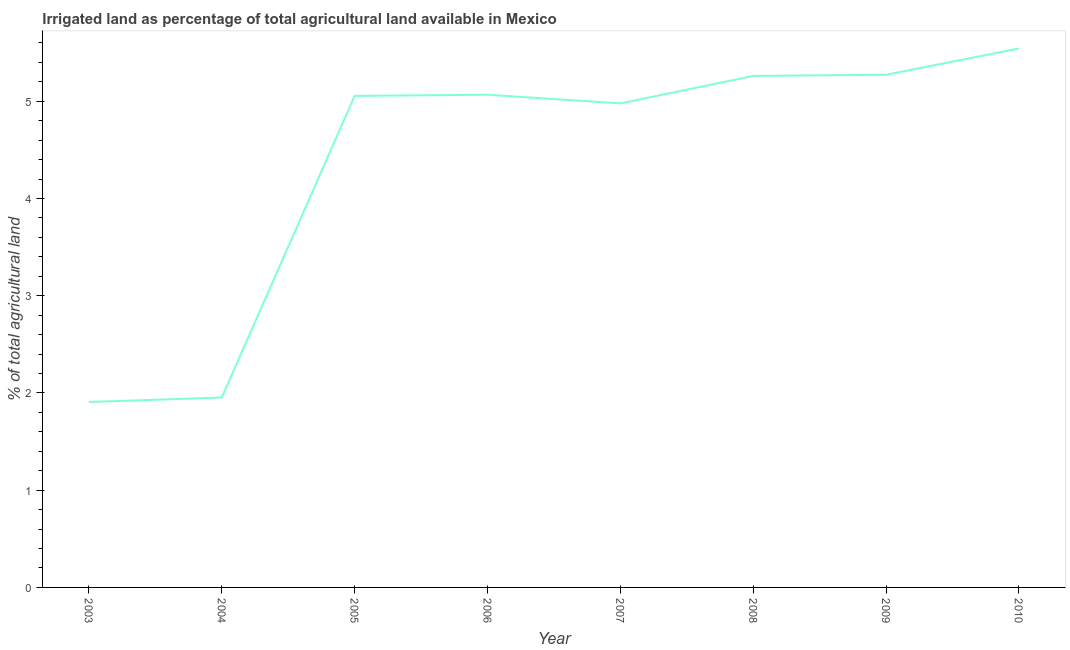What is the percentage of agricultural irrigated land in 2009?
Provide a short and direct response. 5.27. Across all years, what is the maximum percentage of agricultural irrigated land?
Make the answer very short. 5.54. Across all years, what is the minimum percentage of agricultural irrigated land?
Provide a short and direct response. 1.91. In which year was the percentage of agricultural irrigated land maximum?
Offer a terse response. 2010. What is the sum of the percentage of agricultural irrigated land?
Provide a succinct answer. 35.03. What is the difference between the percentage of agricultural irrigated land in 2008 and 2009?
Offer a terse response. -0.01. What is the average percentage of agricultural irrigated land per year?
Provide a short and direct response. 4.38. What is the median percentage of agricultural irrigated land?
Provide a succinct answer. 5.06. In how many years, is the percentage of agricultural irrigated land greater than 3.8 %?
Provide a short and direct response. 6. Do a majority of the years between 2009 and 2007 (inclusive) have percentage of agricultural irrigated land greater than 1.4 %?
Your answer should be very brief. No. What is the ratio of the percentage of agricultural irrigated land in 2005 to that in 2008?
Your answer should be compact. 0.96. Is the percentage of agricultural irrigated land in 2006 less than that in 2009?
Give a very brief answer. Yes. Is the difference between the percentage of agricultural irrigated land in 2007 and 2010 greater than the difference between any two years?
Your response must be concise. No. What is the difference between the highest and the second highest percentage of agricultural irrigated land?
Your answer should be very brief. 0.27. What is the difference between the highest and the lowest percentage of agricultural irrigated land?
Provide a short and direct response. 3.64. In how many years, is the percentage of agricultural irrigated land greater than the average percentage of agricultural irrigated land taken over all years?
Your answer should be very brief. 6. Does the percentage of agricultural irrigated land monotonically increase over the years?
Give a very brief answer. No. How many lines are there?
Keep it short and to the point. 1. How many years are there in the graph?
Your answer should be compact. 8. What is the difference between two consecutive major ticks on the Y-axis?
Your answer should be compact. 1. Are the values on the major ticks of Y-axis written in scientific E-notation?
Ensure brevity in your answer.  No. Does the graph contain any zero values?
Ensure brevity in your answer.  No. Does the graph contain grids?
Your answer should be compact. No. What is the title of the graph?
Keep it short and to the point. Irrigated land as percentage of total agricultural land available in Mexico. What is the label or title of the X-axis?
Keep it short and to the point. Year. What is the label or title of the Y-axis?
Provide a succinct answer. % of total agricultural land. What is the % of total agricultural land of 2003?
Keep it short and to the point. 1.91. What is the % of total agricultural land of 2004?
Give a very brief answer. 1.95. What is the % of total agricultural land of 2005?
Make the answer very short. 5.05. What is the % of total agricultural land in 2006?
Your response must be concise. 5.07. What is the % of total agricultural land in 2007?
Ensure brevity in your answer.  4.98. What is the % of total agricultural land in 2008?
Offer a very short reply. 5.26. What is the % of total agricultural land in 2009?
Provide a short and direct response. 5.27. What is the % of total agricultural land in 2010?
Ensure brevity in your answer.  5.54. What is the difference between the % of total agricultural land in 2003 and 2004?
Your response must be concise. -0.05. What is the difference between the % of total agricultural land in 2003 and 2005?
Offer a very short reply. -3.15. What is the difference between the % of total agricultural land in 2003 and 2006?
Your answer should be compact. -3.16. What is the difference between the % of total agricultural land in 2003 and 2007?
Your response must be concise. -3.07. What is the difference between the % of total agricultural land in 2003 and 2008?
Ensure brevity in your answer.  -3.35. What is the difference between the % of total agricultural land in 2003 and 2009?
Provide a short and direct response. -3.37. What is the difference between the % of total agricultural land in 2003 and 2010?
Offer a terse response. -3.64. What is the difference between the % of total agricultural land in 2004 and 2005?
Offer a very short reply. -3.1. What is the difference between the % of total agricultural land in 2004 and 2006?
Give a very brief answer. -3.11. What is the difference between the % of total agricultural land in 2004 and 2007?
Ensure brevity in your answer.  -3.02. What is the difference between the % of total agricultural land in 2004 and 2008?
Keep it short and to the point. -3.31. What is the difference between the % of total agricultural land in 2004 and 2009?
Provide a succinct answer. -3.32. What is the difference between the % of total agricultural land in 2004 and 2010?
Make the answer very short. -3.59. What is the difference between the % of total agricultural land in 2005 and 2006?
Make the answer very short. -0.01. What is the difference between the % of total agricultural land in 2005 and 2007?
Provide a succinct answer. 0.08. What is the difference between the % of total agricultural land in 2005 and 2008?
Provide a succinct answer. -0.21. What is the difference between the % of total agricultural land in 2005 and 2009?
Ensure brevity in your answer.  -0.22. What is the difference between the % of total agricultural land in 2005 and 2010?
Provide a succinct answer. -0.49. What is the difference between the % of total agricultural land in 2006 and 2007?
Your answer should be very brief. 0.09. What is the difference between the % of total agricultural land in 2006 and 2008?
Provide a succinct answer. -0.19. What is the difference between the % of total agricultural land in 2006 and 2009?
Your answer should be compact. -0.21. What is the difference between the % of total agricultural land in 2006 and 2010?
Offer a very short reply. -0.48. What is the difference between the % of total agricultural land in 2007 and 2008?
Keep it short and to the point. -0.28. What is the difference between the % of total agricultural land in 2007 and 2009?
Offer a terse response. -0.29. What is the difference between the % of total agricultural land in 2007 and 2010?
Offer a very short reply. -0.56. What is the difference between the % of total agricultural land in 2008 and 2009?
Offer a very short reply. -0.01. What is the difference between the % of total agricultural land in 2008 and 2010?
Your response must be concise. -0.28. What is the difference between the % of total agricultural land in 2009 and 2010?
Ensure brevity in your answer.  -0.27. What is the ratio of the % of total agricultural land in 2003 to that in 2005?
Ensure brevity in your answer.  0.38. What is the ratio of the % of total agricultural land in 2003 to that in 2006?
Offer a very short reply. 0.38. What is the ratio of the % of total agricultural land in 2003 to that in 2007?
Offer a very short reply. 0.38. What is the ratio of the % of total agricultural land in 2003 to that in 2008?
Provide a succinct answer. 0.36. What is the ratio of the % of total agricultural land in 2003 to that in 2009?
Your response must be concise. 0.36. What is the ratio of the % of total agricultural land in 2003 to that in 2010?
Offer a terse response. 0.34. What is the ratio of the % of total agricultural land in 2004 to that in 2005?
Offer a very short reply. 0.39. What is the ratio of the % of total agricultural land in 2004 to that in 2006?
Ensure brevity in your answer.  0.39. What is the ratio of the % of total agricultural land in 2004 to that in 2007?
Offer a very short reply. 0.39. What is the ratio of the % of total agricultural land in 2004 to that in 2008?
Provide a succinct answer. 0.37. What is the ratio of the % of total agricultural land in 2004 to that in 2009?
Your response must be concise. 0.37. What is the ratio of the % of total agricultural land in 2004 to that in 2010?
Provide a succinct answer. 0.35. What is the ratio of the % of total agricultural land in 2005 to that in 2006?
Make the answer very short. 1. What is the ratio of the % of total agricultural land in 2005 to that in 2009?
Your answer should be very brief. 0.96. What is the ratio of the % of total agricultural land in 2005 to that in 2010?
Keep it short and to the point. 0.91. What is the ratio of the % of total agricultural land in 2006 to that in 2010?
Ensure brevity in your answer.  0.91. What is the ratio of the % of total agricultural land in 2007 to that in 2008?
Make the answer very short. 0.95. What is the ratio of the % of total agricultural land in 2007 to that in 2009?
Keep it short and to the point. 0.94. What is the ratio of the % of total agricultural land in 2007 to that in 2010?
Offer a very short reply. 0.9. What is the ratio of the % of total agricultural land in 2008 to that in 2009?
Ensure brevity in your answer.  1. What is the ratio of the % of total agricultural land in 2008 to that in 2010?
Make the answer very short. 0.95. What is the ratio of the % of total agricultural land in 2009 to that in 2010?
Offer a terse response. 0.95. 